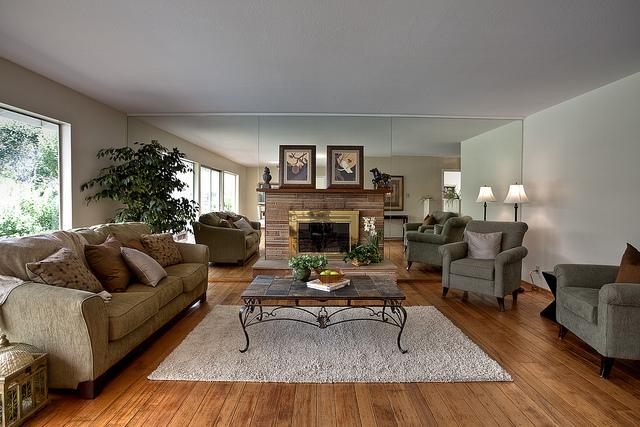What is the gold framed area against the back wall used to hold?

Choices:
A) fire
B) water
C) pictures
D) books fire 